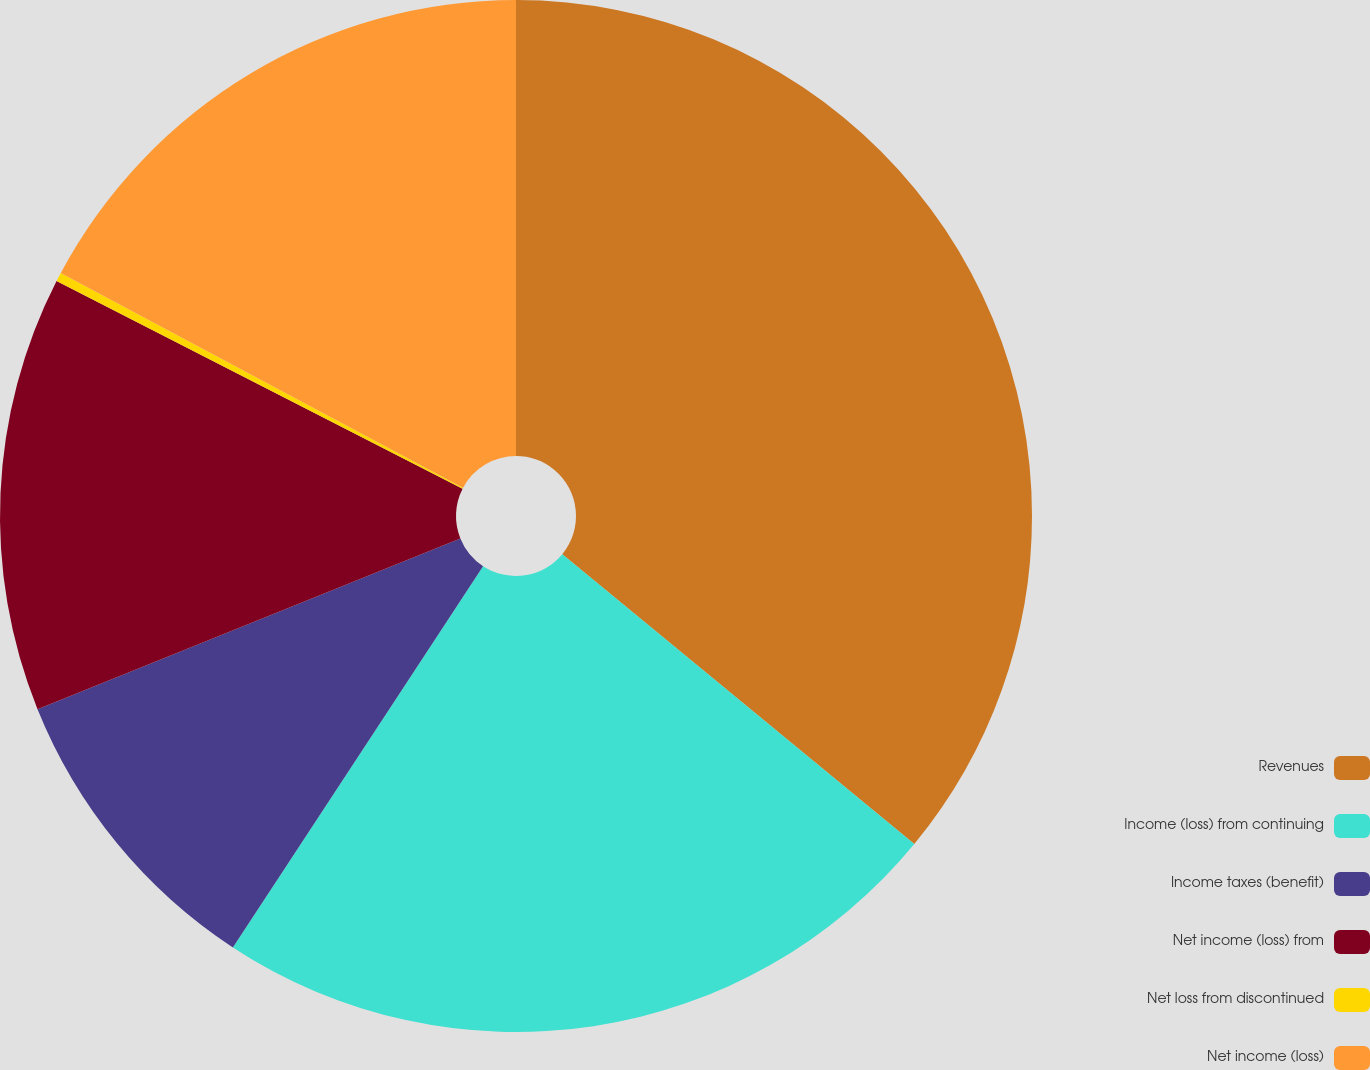<chart> <loc_0><loc_0><loc_500><loc_500><pie_chart><fcel>Revenues<fcel>Income (loss) from continuing<fcel>Income taxes (benefit)<fcel>Net income (loss) from<fcel>Net loss from discontinued<fcel>Net income (loss)<nl><fcel>35.97%<fcel>23.28%<fcel>9.65%<fcel>13.63%<fcel>0.28%<fcel>17.2%<nl></chart> 